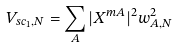<formula> <loc_0><loc_0><loc_500><loc_500>V _ { s c _ { 1 } , N } = \sum _ { A } | X ^ { m A } | ^ { 2 } w _ { A , N } ^ { 2 }</formula> 